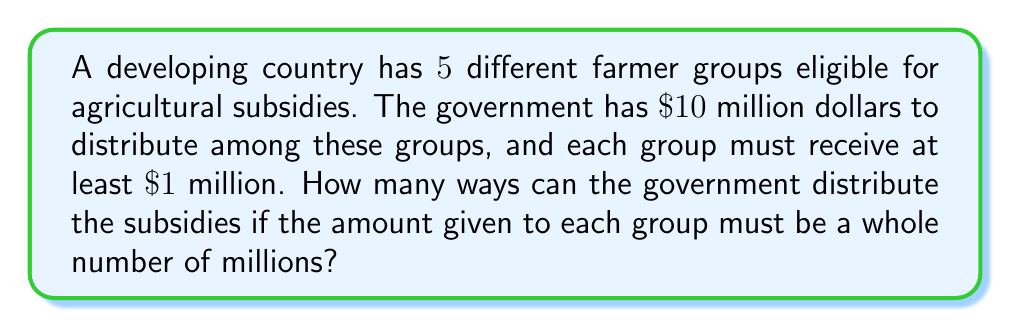Provide a solution to this math problem. Let's approach this step-by-step:

1) First, we need to recognize that this is a stars and bars problem. We're distributing indistinguishable objects (millions of dollars) into distinguishable containers (farmer groups).

2) However, there's a twist: each group must receive at least $1$ million. We can account for this by first giving each group $1$ million, and then distributing the remaining money.

3) After giving each group $1$ million, we have:
   $10 - (1 \times 5) = 5$ million dollars left to distribute.

4) Now, we need to distribute $5$ million dollars among $5$ groups, with no restrictions.

5) This is a classic stars and bars problem. The formula for this is:

   $${n+k-1 \choose k-1}$$

   Where $n$ is the number of indistinguishable objects (millions of dollars) and $k$ is the number of distinguishable containers (farmer groups).

6) In our case, $n = 5$ and $k = 5$. So we have:

   $${5+5-1 \choose 5-1} = {9 \choose 4}$$

7) We can calculate this:

   $${9 \choose 4} = \frac{9!}{4!(9-4)!} = \frac{9!}{4!5!} = 126$$

Therefore, there are 126 ways to distribute the subsidies.
Answer: 126 